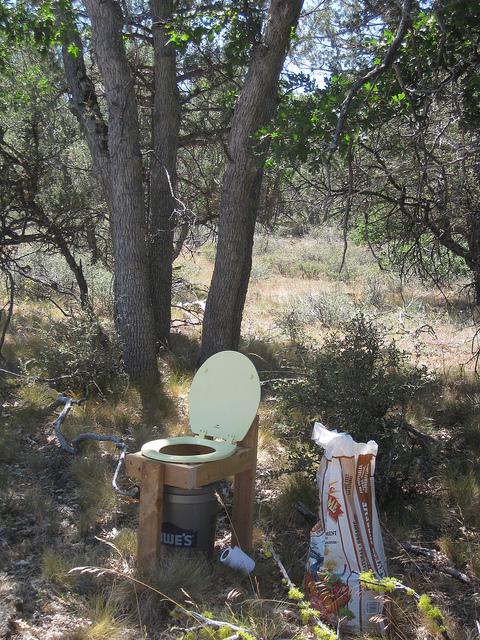Does this toilet get used?
Keep it brief. Yes. Is there water attached to this toilet?
Concise answer only. No. Is there any toilet paper next to the toilet?
Answer briefly. Yes. 